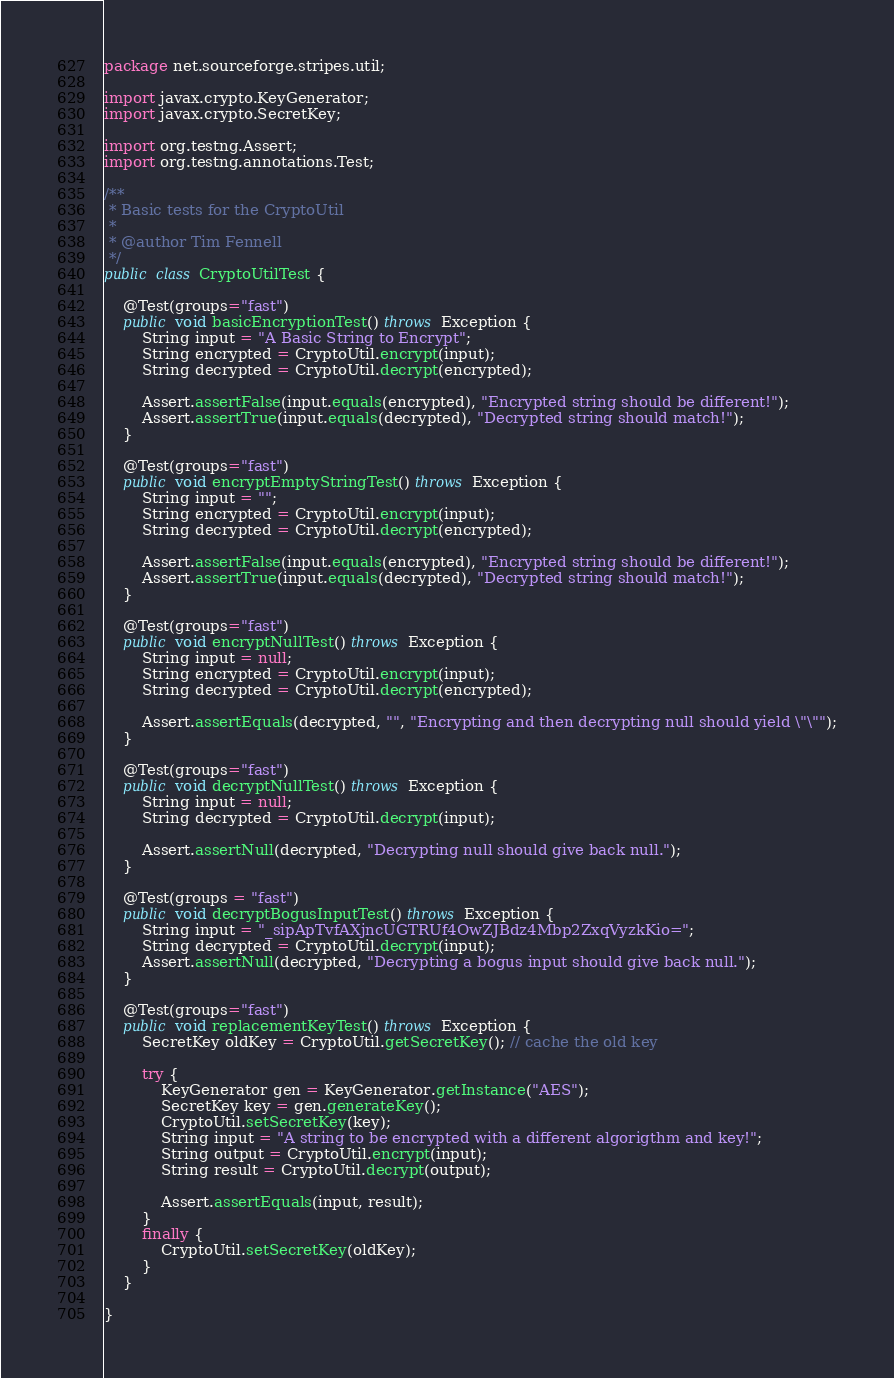Convert code to text. <code><loc_0><loc_0><loc_500><loc_500><_Java_>package net.sourceforge.stripes.util;

import javax.crypto.KeyGenerator;
import javax.crypto.SecretKey;

import org.testng.Assert;
import org.testng.annotations.Test;

/**
 * Basic tests for the CryptoUtil
 *
 * @author Tim Fennell
 */
public class CryptoUtilTest {

    @Test(groups="fast")
    public void basicEncryptionTest() throws Exception {
        String input = "A Basic String to Encrypt";
        String encrypted = CryptoUtil.encrypt(input);
        String decrypted = CryptoUtil.decrypt(encrypted);

        Assert.assertFalse(input.equals(encrypted), "Encrypted string should be different!");
        Assert.assertTrue(input.equals(decrypted), "Decrypted string should match!");
    }

    @Test(groups="fast")
    public void encryptEmptyStringTest() throws Exception {
        String input = "";
        String encrypted = CryptoUtil.encrypt(input);
        String decrypted = CryptoUtil.decrypt(encrypted);

        Assert.assertFalse(input.equals(encrypted), "Encrypted string should be different!");
        Assert.assertTrue(input.equals(decrypted), "Decrypted string should match!");
    }

    @Test(groups="fast")
    public void encryptNullTest() throws Exception {
        String input = null;
        String encrypted = CryptoUtil.encrypt(input);
        String decrypted = CryptoUtil.decrypt(encrypted);

        Assert.assertEquals(decrypted, "", "Encrypting and then decrypting null should yield \"\"");
    }

    @Test(groups="fast")
    public void decryptNullTest() throws Exception {
        String input = null;
        String decrypted = CryptoUtil.decrypt(input);

        Assert.assertNull(decrypted, "Decrypting null should give back null.");
    }
    
    @Test(groups = "fast")
    public void decryptBogusInputTest() throws Exception {
        String input = "_sipApTvfAXjncUGTRUf4OwZJBdz4Mbp2ZxqVyzkKio=";
        String decrypted = CryptoUtil.decrypt(input);
        Assert.assertNull(decrypted, "Decrypting a bogus input should give back null.");
    }

    @Test(groups="fast")
    public void replacementKeyTest() throws Exception {
        SecretKey oldKey = CryptoUtil.getSecretKey(); // cache the old key

        try {
            KeyGenerator gen = KeyGenerator.getInstance("AES");
            SecretKey key = gen.generateKey();
            CryptoUtil.setSecretKey(key);
            String input = "A string to be encrypted with a different algorigthm and key!";
            String output = CryptoUtil.encrypt(input);
            String result = CryptoUtil.decrypt(output);

            Assert.assertEquals(input, result);
        }
        finally {
            CryptoUtil.setSecretKey(oldKey);
        }
    }

}
</code> 